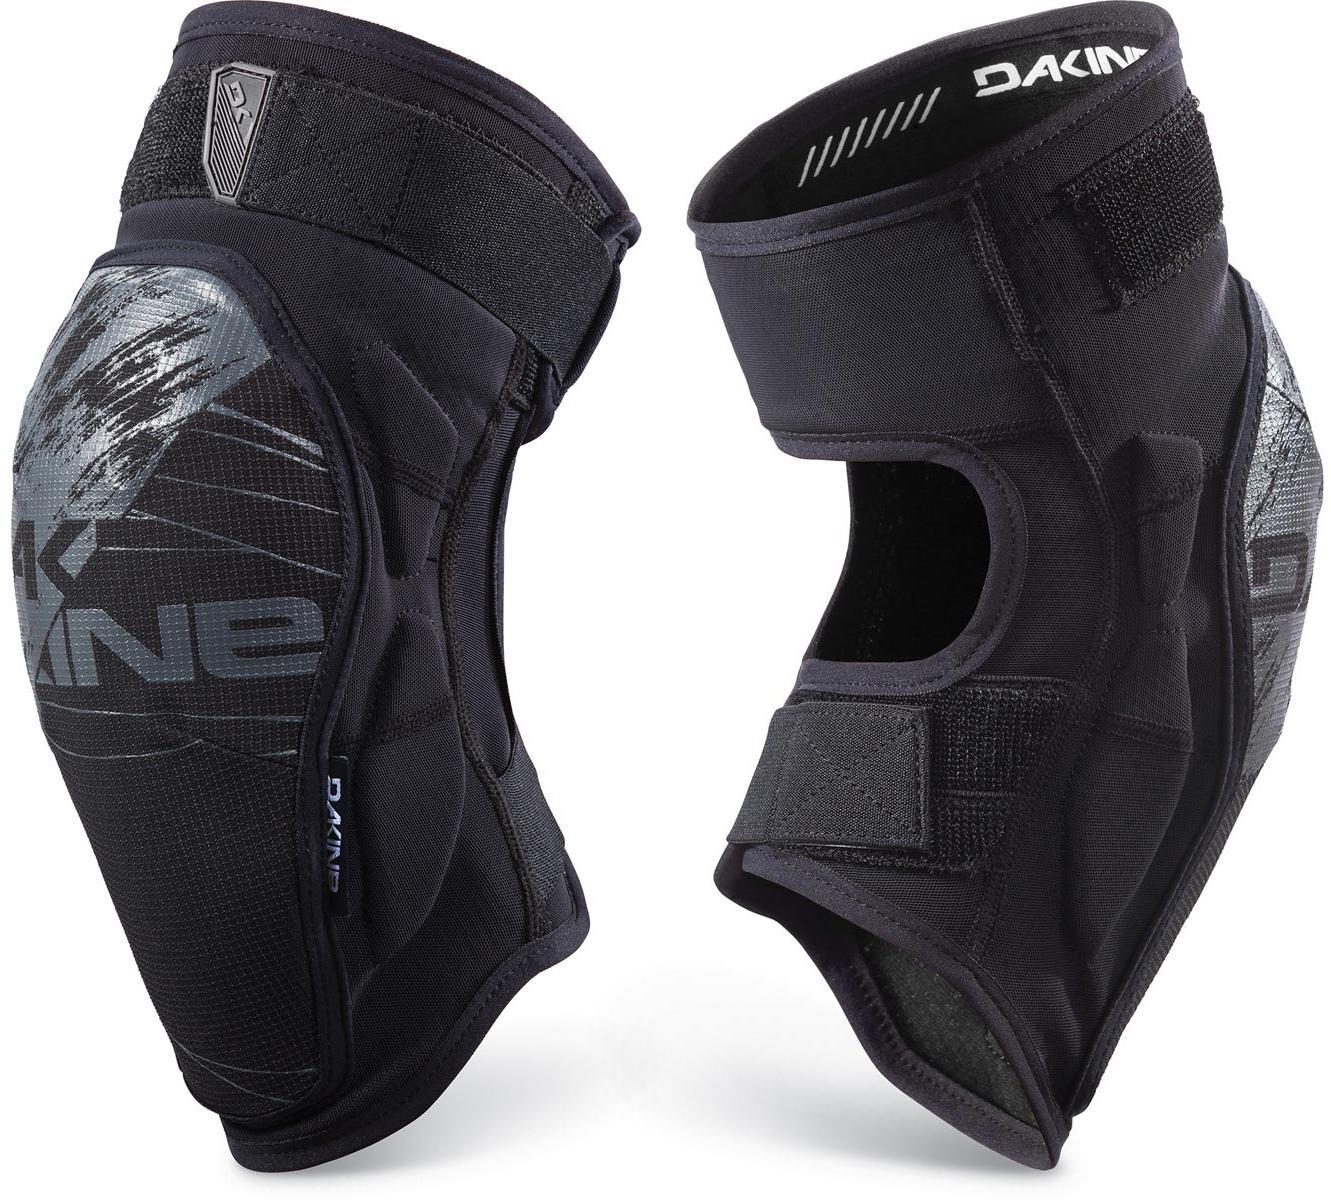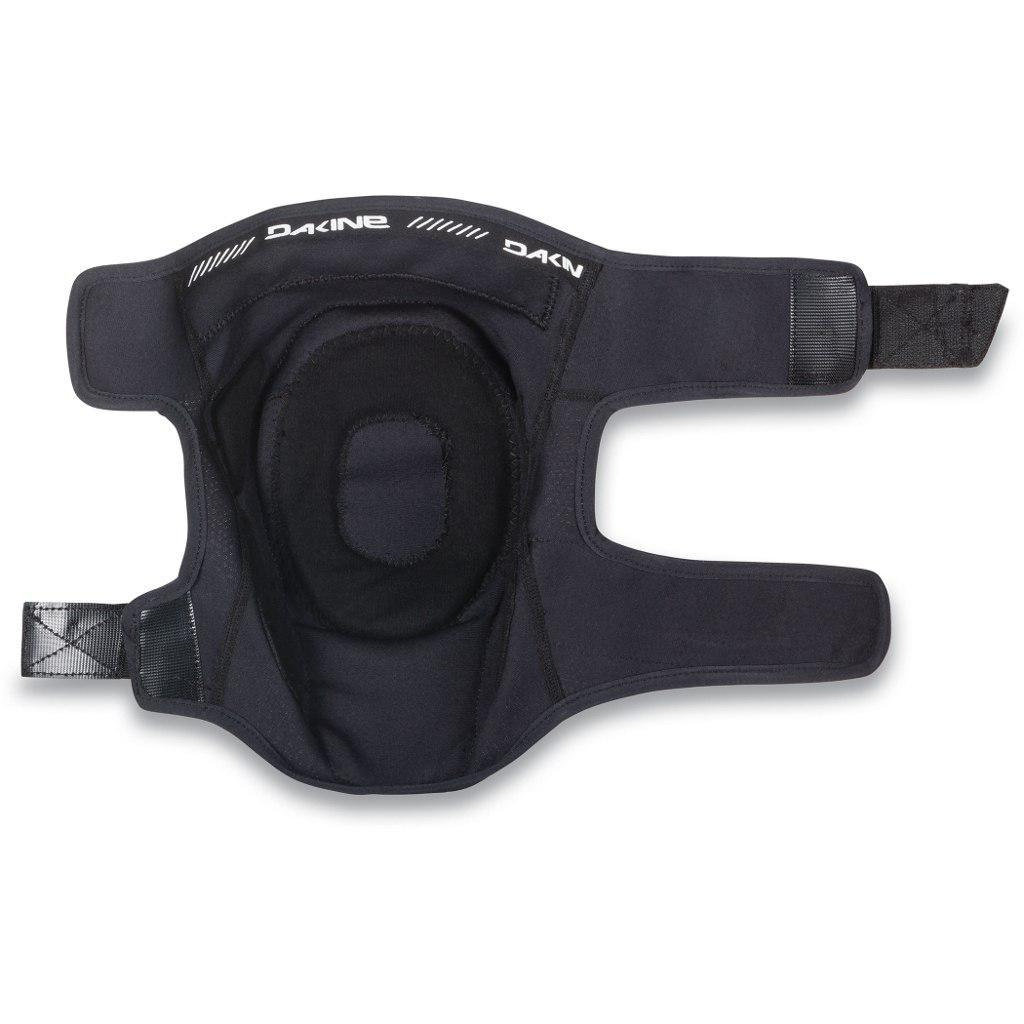The first image is the image on the left, the second image is the image on the right. Given the left and right images, does the statement "Both pads are facing in the same direction." hold true? Answer yes or no. No. 